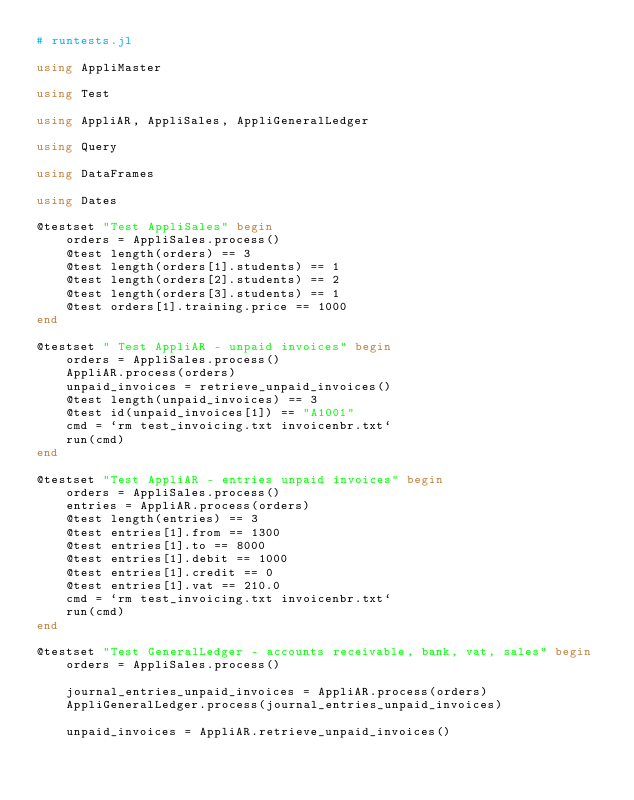Convert code to text. <code><loc_0><loc_0><loc_500><loc_500><_Julia_># runtests.jl

using AppliMaster

using Test

using AppliAR, AppliSales, AppliGeneralLedger

using Query

using DataFrames

using Dates

@testset "Test AppliSales" begin
    orders = AppliSales.process()
    @test length(orders) == 3
    @test length(orders[1].students) == 1
    @test length(orders[2].students) == 2
    @test length(orders[3].students) == 1
    @test orders[1].training.price == 1000
end

@testset " Test AppliAR - unpaid invoices" begin
    orders = AppliSales.process()
    AppliAR.process(orders)
    unpaid_invoices = retrieve_unpaid_invoices()
    @test length(unpaid_invoices) == 3
    @test id(unpaid_invoices[1]) == "A1001"
    cmd = `rm test_invoicing.txt invoicenbr.txt`
    run(cmd)
end

@testset "Test AppliAR - entries unpaid invoices" begin
    orders = AppliSales.process()
    entries = AppliAR.process(orders)
    @test length(entries) == 3
    @test entries[1].from == 1300
    @test entries[1].to == 8000
    @test entries[1].debit == 1000
    @test entries[1].credit == 0
    @test entries[1].vat == 210.0
    cmd = `rm test_invoicing.txt invoicenbr.txt`
    run(cmd)
end

@testset "Test GeneralLedger - accounts receivable, bank, vat, sales" begin
    orders = AppliSales.process()

    journal_entries_unpaid_invoices = AppliAR.process(orders)
    AppliGeneralLedger.process(journal_entries_unpaid_invoices)

    unpaid_invoices = AppliAR.retrieve_unpaid_invoices()</code> 